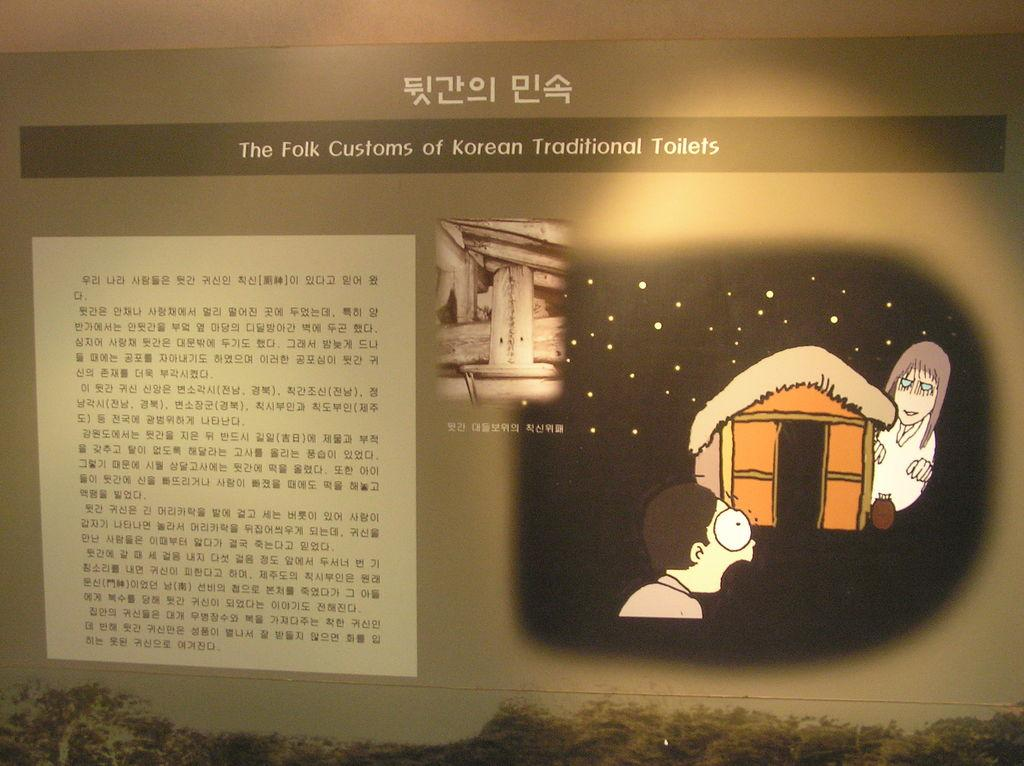Provide a one-sentence caption for the provided image. An information panel is lit up showing a scared man seeing a ghost with the words "The Folk Customs of Korean Traditional Toilets". 